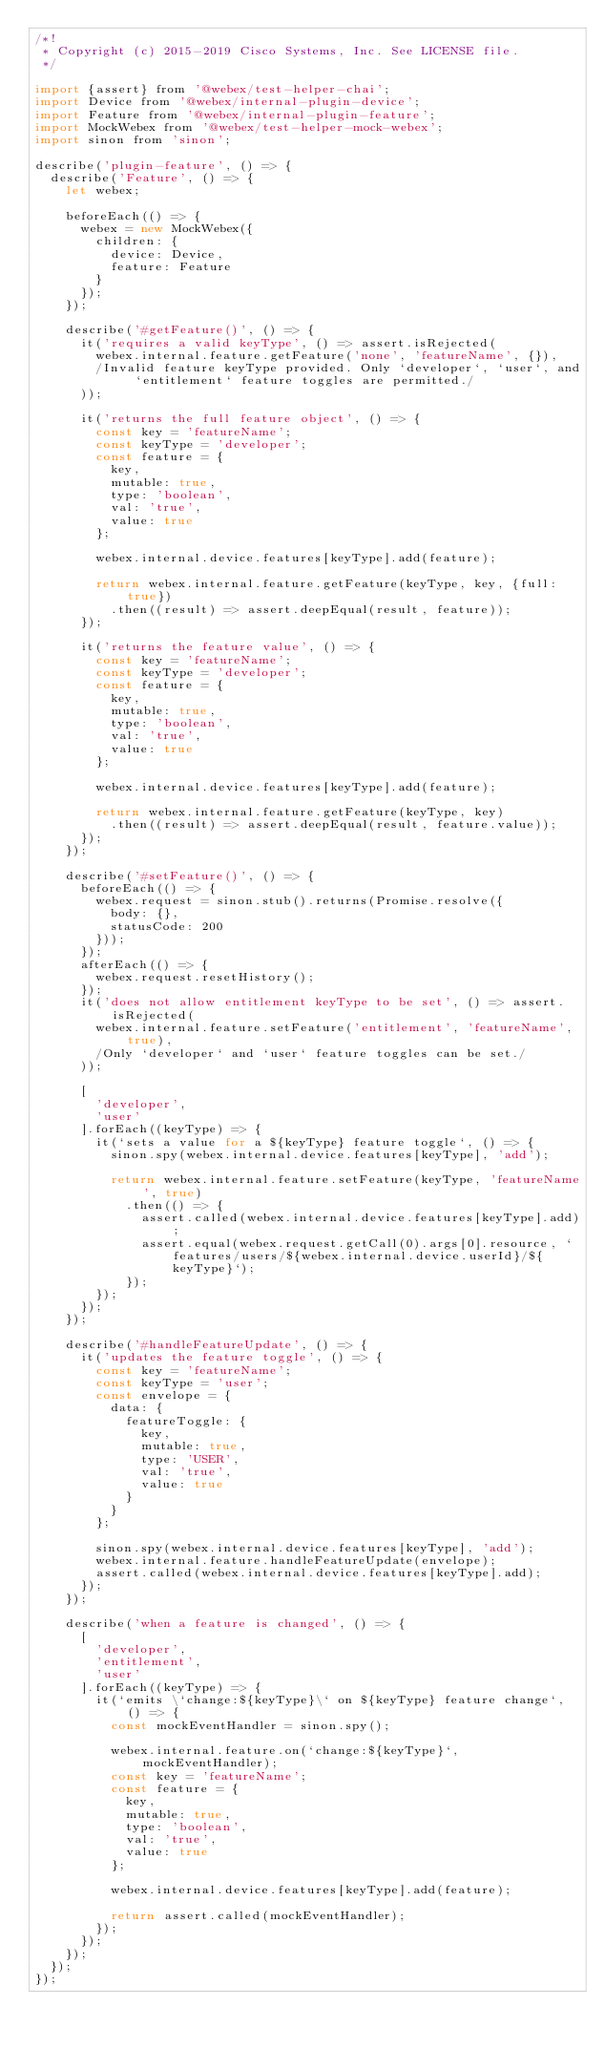Convert code to text. <code><loc_0><loc_0><loc_500><loc_500><_JavaScript_>/*!
 * Copyright (c) 2015-2019 Cisco Systems, Inc. See LICENSE file.
 */

import {assert} from '@webex/test-helper-chai';
import Device from '@webex/internal-plugin-device';
import Feature from '@webex/internal-plugin-feature';
import MockWebex from '@webex/test-helper-mock-webex';
import sinon from 'sinon';

describe('plugin-feature', () => {
  describe('Feature', () => {
    let webex;

    beforeEach(() => {
      webex = new MockWebex({
        children: {
          device: Device,
          feature: Feature
        }
      });
    });

    describe('#getFeature()', () => {
      it('requires a valid keyType', () => assert.isRejected(
        webex.internal.feature.getFeature('none', 'featureName', {}),
        /Invalid feature keyType provided. Only `developer`, `user`, and `entitlement` feature toggles are permitted./
      ));

      it('returns the full feature object', () => {
        const key = 'featureName';
        const keyType = 'developer';
        const feature = {
          key,
          mutable: true,
          type: 'boolean',
          val: 'true',
          value: true
        };

        webex.internal.device.features[keyType].add(feature);

        return webex.internal.feature.getFeature(keyType, key, {full: true})
          .then((result) => assert.deepEqual(result, feature));
      });

      it('returns the feature value', () => {
        const key = 'featureName';
        const keyType = 'developer';
        const feature = {
          key,
          mutable: true,
          type: 'boolean',
          val: 'true',
          value: true
        };

        webex.internal.device.features[keyType].add(feature);

        return webex.internal.feature.getFeature(keyType, key)
          .then((result) => assert.deepEqual(result, feature.value));
      });
    });

    describe('#setFeature()', () => {
      beforeEach(() => {
        webex.request = sinon.stub().returns(Promise.resolve({
          body: {},
          statusCode: 200
        }));
      });
      afterEach(() => {
        webex.request.resetHistory();
      });
      it('does not allow entitlement keyType to be set', () => assert.isRejected(
        webex.internal.feature.setFeature('entitlement', 'featureName', true),
        /Only `developer` and `user` feature toggles can be set./
      ));

      [
        'developer',
        'user'
      ].forEach((keyType) => {
        it(`sets a value for a ${keyType} feature toggle`, () => {
          sinon.spy(webex.internal.device.features[keyType], 'add');

          return webex.internal.feature.setFeature(keyType, 'featureName', true)
            .then(() => {
              assert.called(webex.internal.device.features[keyType].add);
              assert.equal(webex.request.getCall(0).args[0].resource, `features/users/${webex.internal.device.userId}/${keyType}`);
            });
        });
      });
    });

    describe('#handleFeatureUpdate', () => {
      it('updates the feature toggle', () => {
        const key = 'featureName';
        const keyType = 'user';
        const envelope = {
          data: {
            featureToggle: {
              key,
              mutable: true,
              type: 'USER',
              val: 'true',
              value: true
            }
          }
        };

        sinon.spy(webex.internal.device.features[keyType], 'add');
        webex.internal.feature.handleFeatureUpdate(envelope);
        assert.called(webex.internal.device.features[keyType].add);
      });
    });

    describe('when a feature is changed', () => {
      [
        'developer',
        'entitlement',
        'user'
      ].forEach((keyType) => {
        it(`emits \`change:${keyType}\` on ${keyType} feature change`, () => {
          const mockEventHandler = sinon.spy();

          webex.internal.feature.on(`change:${keyType}`, mockEventHandler);
          const key = 'featureName';
          const feature = {
            key,
            mutable: true,
            type: 'boolean',
            val: 'true',
            value: true
          };

          webex.internal.device.features[keyType].add(feature);

          return assert.called(mockEventHandler);
        });
      });
    });
  });
});
</code> 